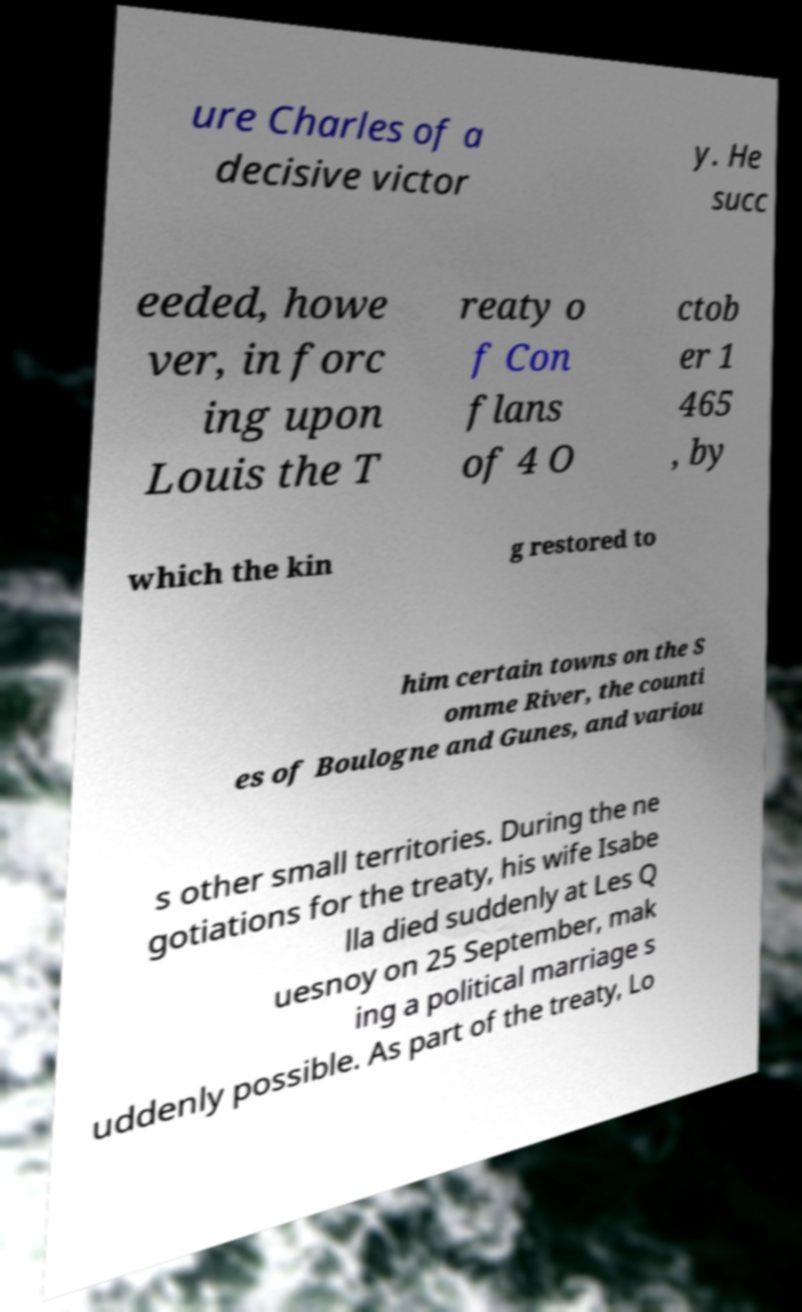Could you extract and type out the text from this image? ure Charles of a decisive victor y. He succ eeded, howe ver, in forc ing upon Louis the T reaty o f Con flans of 4 O ctob er 1 465 , by which the kin g restored to him certain towns on the S omme River, the counti es of Boulogne and Gunes, and variou s other small territories. During the ne gotiations for the treaty, his wife Isabe lla died suddenly at Les Q uesnoy on 25 September, mak ing a political marriage s uddenly possible. As part of the treaty, Lo 